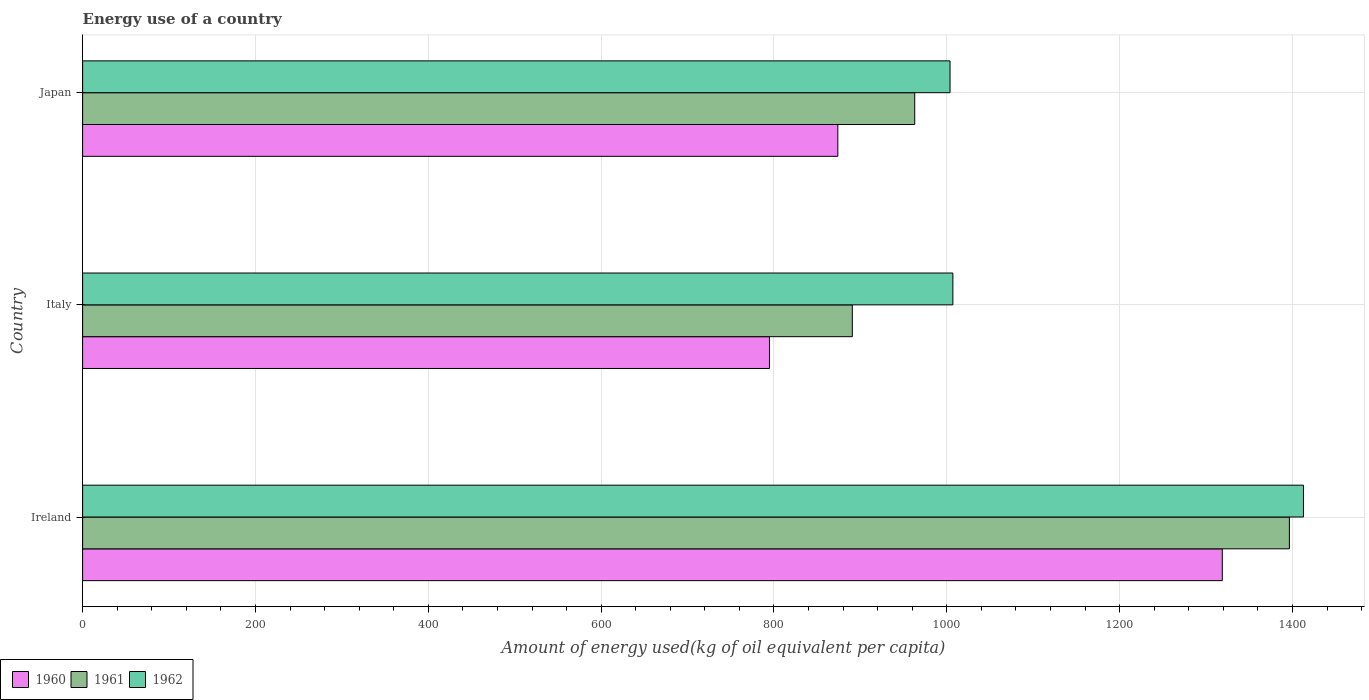How many different coloured bars are there?
Provide a short and direct response. 3. How many groups of bars are there?
Make the answer very short. 3. Are the number of bars per tick equal to the number of legend labels?
Ensure brevity in your answer.  Yes. Are the number of bars on each tick of the Y-axis equal?
Give a very brief answer. Yes. How many bars are there on the 1st tick from the top?
Give a very brief answer. 3. How many bars are there on the 3rd tick from the bottom?
Offer a terse response. 3. In how many cases, is the number of bars for a given country not equal to the number of legend labels?
Provide a short and direct response. 0. What is the amount of energy used in in 1962 in Ireland?
Your answer should be very brief. 1412.73. Across all countries, what is the maximum amount of energy used in in 1961?
Provide a short and direct response. 1396.47. Across all countries, what is the minimum amount of energy used in in 1961?
Provide a succinct answer. 890.69. In which country was the amount of energy used in in 1962 maximum?
Keep it short and to the point. Ireland. In which country was the amount of energy used in in 1961 minimum?
Give a very brief answer. Italy. What is the total amount of energy used in in 1960 in the graph?
Your answer should be very brief. 2987.54. What is the difference between the amount of energy used in in 1962 in Ireland and that in Japan?
Offer a very short reply. 408.98. What is the difference between the amount of energy used in in 1961 in Japan and the amount of energy used in in 1962 in Ireland?
Ensure brevity in your answer.  -449.82. What is the average amount of energy used in in 1961 per country?
Offer a terse response. 1083.35. What is the difference between the amount of energy used in in 1961 and amount of energy used in in 1960 in Italy?
Your answer should be compact. 95.87. In how many countries, is the amount of energy used in in 1962 greater than 760 kg?
Provide a succinct answer. 3. What is the ratio of the amount of energy used in in 1960 in Ireland to that in Japan?
Your answer should be compact. 1.51. Is the amount of energy used in in 1962 in Italy less than that in Japan?
Offer a very short reply. No. Is the difference between the amount of energy used in in 1961 in Ireland and Japan greater than the difference between the amount of energy used in in 1960 in Ireland and Japan?
Offer a terse response. No. What is the difference between the highest and the second highest amount of energy used in in 1961?
Offer a terse response. 433.56. What is the difference between the highest and the lowest amount of energy used in in 1962?
Provide a short and direct response. 408.98. In how many countries, is the amount of energy used in in 1960 greater than the average amount of energy used in in 1960 taken over all countries?
Provide a short and direct response. 1. Is the sum of the amount of energy used in in 1960 in Italy and Japan greater than the maximum amount of energy used in in 1962 across all countries?
Provide a succinct answer. Yes. What does the 1st bar from the top in Italy represents?
Provide a succinct answer. 1962. Are all the bars in the graph horizontal?
Offer a terse response. Yes. Does the graph contain any zero values?
Keep it short and to the point. No. How are the legend labels stacked?
Make the answer very short. Horizontal. What is the title of the graph?
Give a very brief answer. Energy use of a country. Does "2014" appear as one of the legend labels in the graph?
Offer a very short reply. No. What is the label or title of the X-axis?
Offer a very short reply. Amount of energy used(kg of oil equivalent per capita). What is the label or title of the Y-axis?
Ensure brevity in your answer.  Country. What is the Amount of energy used(kg of oil equivalent per capita) of 1960 in Ireland?
Keep it short and to the point. 1318.81. What is the Amount of energy used(kg of oil equivalent per capita) in 1961 in Ireland?
Give a very brief answer. 1396.47. What is the Amount of energy used(kg of oil equivalent per capita) of 1962 in Ireland?
Offer a terse response. 1412.73. What is the Amount of energy used(kg of oil equivalent per capita) of 1960 in Italy?
Your response must be concise. 794.82. What is the Amount of energy used(kg of oil equivalent per capita) of 1961 in Italy?
Provide a succinct answer. 890.69. What is the Amount of energy used(kg of oil equivalent per capita) of 1962 in Italy?
Your answer should be very brief. 1007.05. What is the Amount of energy used(kg of oil equivalent per capita) in 1960 in Japan?
Provide a short and direct response. 873.91. What is the Amount of energy used(kg of oil equivalent per capita) in 1961 in Japan?
Keep it short and to the point. 962.91. What is the Amount of energy used(kg of oil equivalent per capita) in 1962 in Japan?
Your answer should be very brief. 1003.75. Across all countries, what is the maximum Amount of energy used(kg of oil equivalent per capita) of 1960?
Offer a very short reply. 1318.81. Across all countries, what is the maximum Amount of energy used(kg of oil equivalent per capita) in 1961?
Provide a succinct answer. 1396.47. Across all countries, what is the maximum Amount of energy used(kg of oil equivalent per capita) of 1962?
Keep it short and to the point. 1412.73. Across all countries, what is the minimum Amount of energy used(kg of oil equivalent per capita) in 1960?
Your answer should be very brief. 794.82. Across all countries, what is the minimum Amount of energy used(kg of oil equivalent per capita) in 1961?
Ensure brevity in your answer.  890.69. Across all countries, what is the minimum Amount of energy used(kg of oil equivalent per capita) in 1962?
Ensure brevity in your answer.  1003.75. What is the total Amount of energy used(kg of oil equivalent per capita) of 1960 in the graph?
Your answer should be compact. 2987.54. What is the total Amount of energy used(kg of oil equivalent per capita) in 1961 in the graph?
Your answer should be compact. 3250.06. What is the total Amount of energy used(kg of oil equivalent per capita) in 1962 in the graph?
Provide a short and direct response. 3423.53. What is the difference between the Amount of energy used(kg of oil equivalent per capita) of 1960 in Ireland and that in Italy?
Give a very brief answer. 524. What is the difference between the Amount of energy used(kg of oil equivalent per capita) of 1961 in Ireland and that in Italy?
Your answer should be very brief. 505.78. What is the difference between the Amount of energy used(kg of oil equivalent per capita) in 1962 in Ireland and that in Italy?
Keep it short and to the point. 405.68. What is the difference between the Amount of energy used(kg of oil equivalent per capita) of 1960 in Ireland and that in Japan?
Offer a terse response. 444.9. What is the difference between the Amount of energy used(kg of oil equivalent per capita) in 1961 in Ireland and that in Japan?
Your answer should be very brief. 433.56. What is the difference between the Amount of energy used(kg of oil equivalent per capita) of 1962 in Ireland and that in Japan?
Provide a succinct answer. 408.98. What is the difference between the Amount of energy used(kg of oil equivalent per capita) of 1960 in Italy and that in Japan?
Your answer should be compact. -79.09. What is the difference between the Amount of energy used(kg of oil equivalent per capita) in 1961 in Italy and that in Japan?
Provide a short and direct response. -72.22. What is the difference between the Amount of energy used(kg of oil equivalent per capita) in 1962 in Italy and that in Japan?
Your response must be concise. 3.3. What is the difference between the Amount of energy used(kg of oil equivalent per capita) in 1960 in Ireland and the Amount of energy used(kg of oil equivalent per capita) in 1961 in Italy?
Provide a succinct answer. 428.12. What is the difference between the Amount of energy used(kg of oil equivalent per capita) of 1960 in Ireland and the Amount of energy used(kg of oil equivalent per capita) of 1962 in Italy?
Offer a terse response. 311.76. What is the difference between the Amount of energy used(kg of oil equivalent per capita) of 1961 in Ireland and the Amount of energy used(kg of oil equivalent per capita) of 1962 in Italy?
Keep it short and to the point. 389.42. What is the difference between the Amount of energy used(kg of oil equivalent per capita) in 1960 in Ireland and the Amount of energy used(kg of oil equivalent per capita) in 1961 in Japan?
Provide a succinct answer. 355.91. What is the difference between the Amount of energy used(kg of oil equivalent per capita) in 1960 in Ireland and the Amount of energy used(kg of oil equivalent per capita) in 1962 in Japan?
Your answer should be compact. 315.06. What is the difference between the Amount of energy used(kg of oil equivalent per capita) of 1961 in Ireland and the Amount of energy used(kg of oil equivalent per capita) of 1962 in Japan?
Offer a terse response. 392.71. What is the difference between the Amount of energy used(kg of oil equivalent per capita) in 1960 in Italy and the Amount of energy used(kg of oil equivalent per capita) in 1961 in Japan?
Offer a very short reply. -168.09. What is the difference between the Amount of energy used(kg of oil equivalent per capita) in 1960 in Italy and the Amount of energy used(kg of oil equivalent per capita) in 1962 in Japan?
Your response must be concise. -208.94. What is the difference between the Amount of energy used(kg of oil equivalent per capita) of 1961 in Italy and the Amount of energy used(kg of oil equivalent per capita) of 1962 in Japan?
Offer a terse response. -113.06. What is the average Amount of energy used(kg of oil equivalent per capita) in 1960 per country?
Give a very brief answer. 995.85. What is the average Amount of energy used(kg of oil equivalent per capita) in 1961 per country?
Offer a very short reply. 1083.35. What is the average Amount of energy used(kg of oil equivalent per capita) in 1962 per country?
Your answer should be compact. 1141.18. What is the difference between the Amount of energy used(kg of oil equivalent per capita) of 1960 and Amount of energy used(kg of oil equivalent per capita) of 1961 in Ireland?
Make the answer very short. -77.65. What is the difference between the Amount of energy used(kg of oil equivalent per capita) of 1960 and Amount of energy used(kg of oil equivalent per capita) of 1962 in Ireland?
Offer a very short reply. -93.92. What is the difference between the Amount of energy used(kg of oil equivalent per capita) in 1961 and Amount of energy used(kg of oil equivalent per capita) in 1962 in Ireland?
Your answer should be very brief. -16.26. What is the difference between the Amount of energy used(kg of oil equivalent per capita) in 1960 and Amount of energy used(kg of oil equivalent per capita) in 1961 in Italy?
Offer a very short reply. -95.87. What is the difference between the Amount of energy used(kg of oil equivalent per capita) in 1960 and Amount of energy used(kg of oil equivalent per capita) in 1962 in Italy?
Your answer should be very brief. -212.23. What is the difference between the Amount of energy used(kg of oil equivalent per capita) of 1961 and Amount of energy used(kg of oil equivalent per capita) of 1962 in Italy?
Your response must be concise. -116.36. What is the difference between the Amount of energy used(kg of oil equivalent per capita) of 1960 and Amount of energy used(kg of oil equivalent per capita) of 1961 in Japan?
Your answer should be compact. -89. What is the difference between the Amount of energy used(kg of oil equivalent per capita) of 1960 and Amount of energy used(kg of oil equivalent per capita) of 1962 in Japan?
Offer a terse response. -129.84. What is the difference between the Amount of energy used(kg of oil equivalent per capita) of 1961 and Amount of energy used(kg of oil equivalent per capita) of 1962 in Japan?
Offer a terse response. -40.85. What is the ratio of the Amount of energy used(kg of oil equivalent per capita) in 1960 in Ireland to that in Italy?
Offer a terse response. 1.66. What is the ratio of the Amount of energy used(kg of oil equivalent per capita) in 1961 in Ireland to that in Italy?
Provide a succinct answer. 1.57. What is the ratio of the Amount of energy used(kg of oil equivalent per capita) in 1962 in Ireland to that in Italy?
Make the answer very short. 1.4. What is the ratio of the Amount of energy used(kg of oil equivalent per capita) of 1960 in Ireland to that in Japan?
Give a very brief answer. 1.51. What is the ratio of the Amount of energy used(kg of oil equivalent per capita) of 1961 in Ireland to that in Japan?
Provide a succinct answer. 1.45. What is the ratio of the Amount of energy used(kg of oil equivalent per capita) of 1962 in Ireland to that in Japan?
Your answer should be very brief. 1.41. What is the ratio of the Amount of energy used(kg of oil equivalent per capita) of 1960 in Italy to that in Japan?
Provide a short and direct response. 0.91. What is the ratio of the Amount of energy used(kg of oil equivalent per capita) in 1961 in Italy to that in Japan?
Make the answer very short. 0.93. What is the ratio of the Amount of energy used(kg of oil equivalent per capita) of 1962 in Italy to that in Japan?
Ensure brevity in your answer.  1. What is the difference between the highest and the second highest Amount of energy used(kg of oil equivalent per capita) in 1960?
Provide a short and direct response. 444.9. What is the difference between the highest and the second highest Amount of energy used(kg of oil equivalent per capita) in 1961?
Give a very brief answer. 433.56. What is the difference between the highest and the second highest Amount of energy used(kg of oil equivalent per capita) in 1962?
Provide a succinct answer. 405.68. What is the difference between the highest and the lowest Amount of energy used(kg of oil equivalent per capita) in 1960?
Provide a short and direct response. 524. What is the difference between the highest and the lowest Amount of energy used(kg of oil equivalent per capita) in 1961?
Offer a terse response. 505.78. What is the difference between the highest and the lowest Amount of energy used(kg of oil equivalent per capita) of 1962?
Your response must be concise. 408.98. 